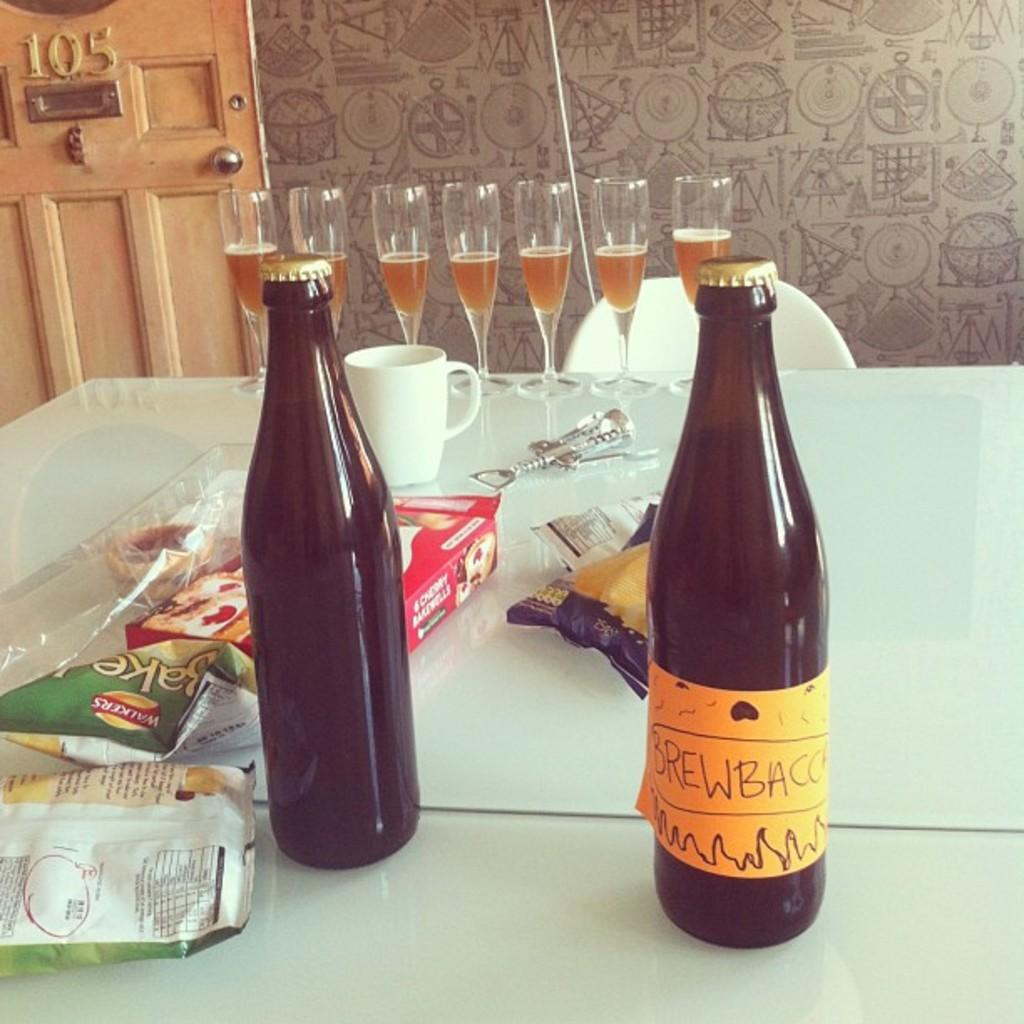What does the bottle say?
Ensure brevity in your answer.  Brewbacc. How many wine glasses can you see?
Offer a terse response. Answering does not require reading text in the image. 